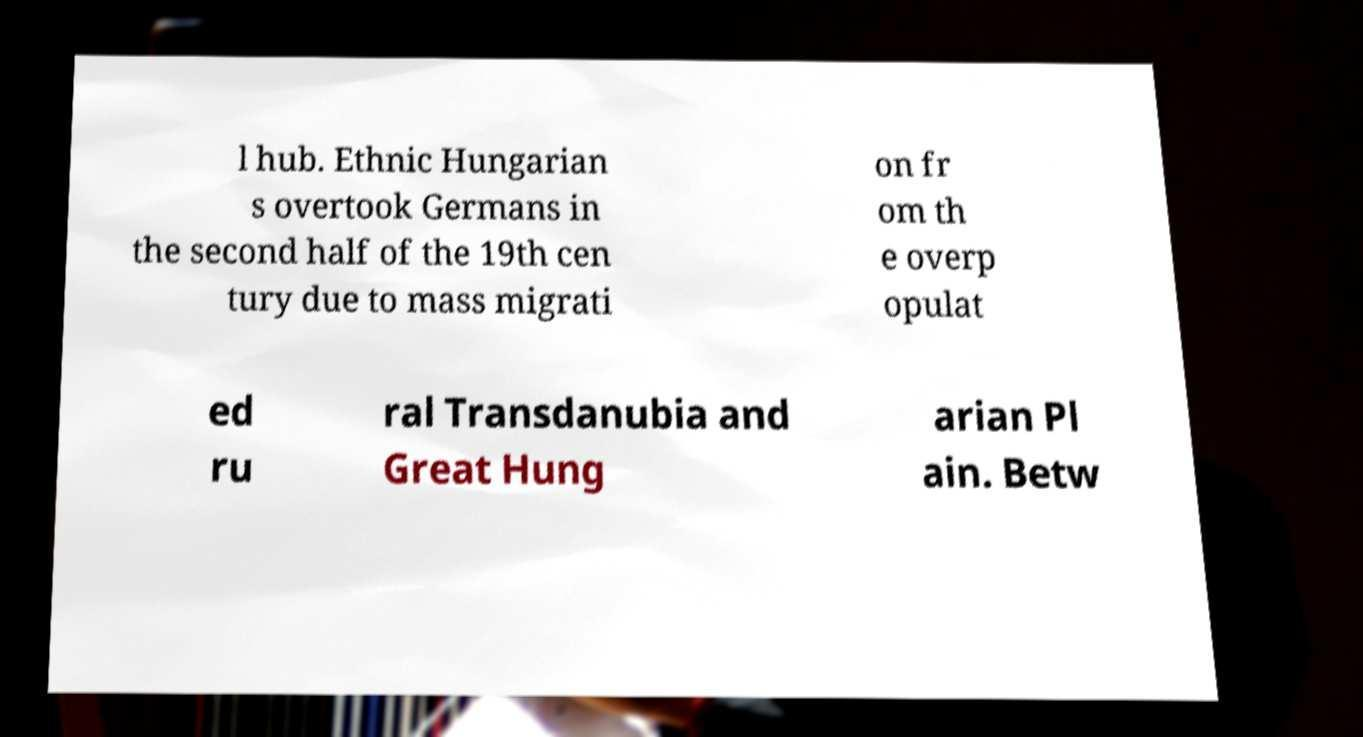Can you read and provide the text displayed in the image?This photo seems to have some interesting text. Can you extract and type it out for me? l hub. Ethnic Hungarian s overtook Germans in the second half of the 19th cen tury due to mass migrati on fr om th e overp opulat ed ru ral Transdanubia and Great Hung arian Pl ain. Betw 